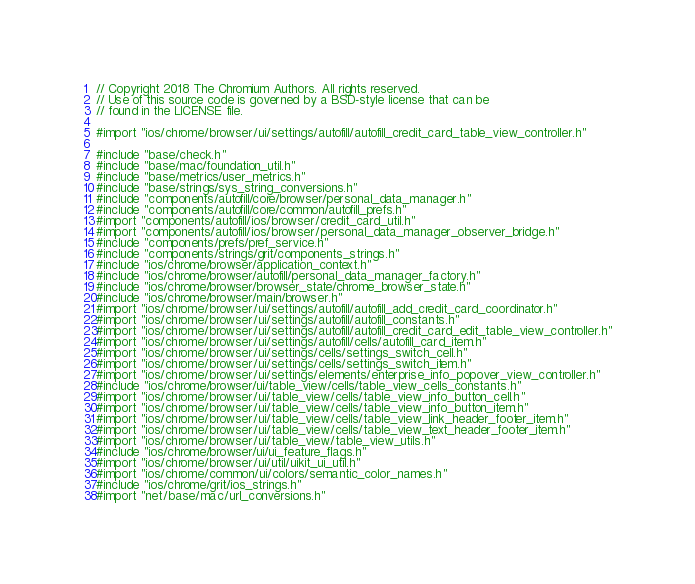<code> <loc_0><loc_0><loc_500><loc_500><_ObjectiveC_>// Copyright 2018 The Chromium Authors. All rights reserved.
// Use of this source code is governed by a BSD-style license that can be
// found in the LICENSE file.

#import "ios/chrome/browser/ui/settings/autofill/autofill_credit_card_table_view_controller.h"

#include "base/check.h"
#include "base/mac/foundation_util.h"
#include "base/metrics/user_metrics.h"
#include "base/strings/sys_string_conversions.h"
#include "components/autofill/core/browser/personal_data_manager.h"
#include "components/autofill/core/common/autofill_prefs.h"
#import "components/autofill/ios/browser/credit_card_util.h"
#import "components/autofill/ios/browser/personal_data_manager_observer_bridge.h"
#include "components/prefs/pref_service.h"
#include "components/strings/grit/components_strings.h"
#include "ios/chrome/browser/application_context.h"
#include "ios/chrome/browser/autofill/personal_data_manager_factory.h"
#include "ios/chrome/browser/browser_state/chrome_browser_state.h"
#include "ios/chrome/browser/main/browser.h"
#import "ios/chrome/browser/ui/settings/autofill/autofill_add_credit_card_coordinator.h"
#import "ios/chrome/browser/ui/settings/autofill/autofill_constants.h"
#import "ios/chrome/browser/ui/settings/autofill/autofill_credit_card_edit_table_view_controller.h"
#import "ios/chrome/browser/ui/settings/autofill/cells/autofill_card_item.h"
#import "ios/chrome/browser/ui/settings/cells/settings_switch_cell.h"
#import "ios/chrome/browser/ui/settings/cells/settings_switch_item.h"
#import "ios/chrome/browser/ui/settings/elements/enterprise_info_popover_view_controller.h"
#include "ios/chrome/browser/ui/table_view/cells/table_view_cells_constants.h"
#import "ios/chrome/browser/ui/table_view/cells/table_view_info_button_cell.h"
#import "ios/chrome/browser/ui/table_view/cells/table_view_info_button_item.h"
#import "ios/chrome/browser/ui/table_view/cells/table_view_link_header_footer_item.h"
#import "ios/chrome/browser/ui/table_view/cells/table_view_text_header_footer_item.h"
#import "ios/chrome/browser/ui/table_view/table_view_utils.h"
#include "ios/chrome/browser/ui/ui_feature_flags.h"
#import "ios/chrome/browser/ui/util/uikit_ui_util.h"
#import "ios/chrome/common/ui/colors/semantic_color_names.h"
#include "ios/chrome/grit/ios_strings.h"
#import "net/base/mac/url_conversions.h"</code> 